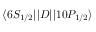Convert formula to latex. <formula><loc_0><loc_0><loc_500><loc_500>{ \langle 6 S _ { 1 / 2 } | | } D { | | 1 0 P _ { 1 / 2 } \rangle }</formula> 